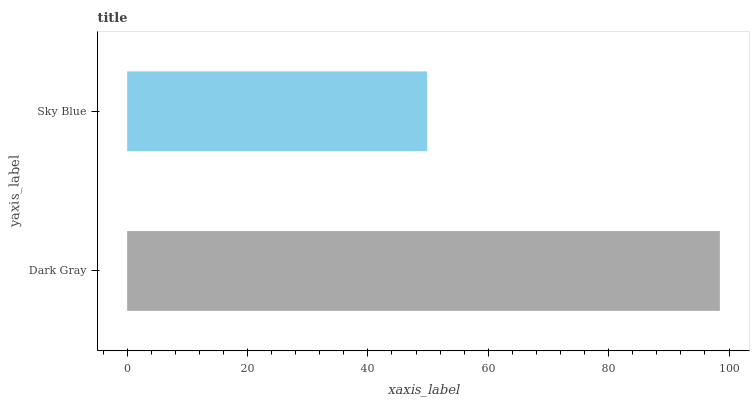Is Sky Blue the minimum?
Answer yes or no. Yes. Is Dark Gray the maximum?
Answer yes or no. Yes. Is Sky Blue the maximum?
Answer yes or no. No. Is Dark Gray greater than Sky Blue?
Answer yes or no. Yes. Is Sky Blue less than Dark Gray?
Answer yes or no. Yes. Is Sky Blue greater than Dark Gray?
Answer yes or no. No. Is Dark Gray less than Sky Blue?
Answer yes or no. No. Is Dark Gray the high median?
Answer yes or no. Yes. Is Sky Blue the low median?
Answer yes or no. Yes. Is Sky Blue the high median?
Answer yes or no. No. Is Dark Gray the low median?
Answer yes or no. No. 